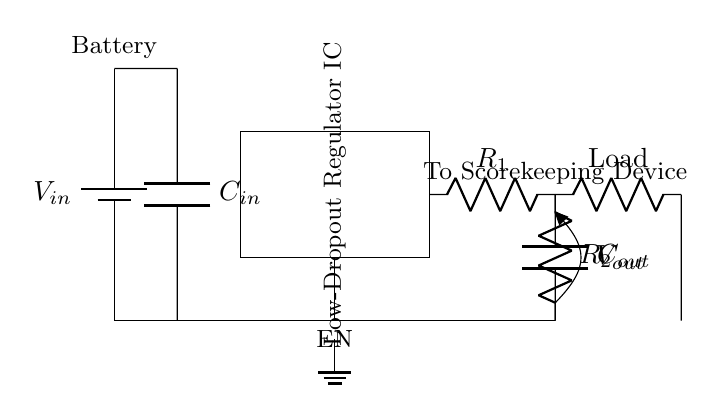What is the type of voltage source used in this circuit? The circuit includes a battery, which is indicated with the label "Battery" at the top left corner. A battery is a type of voltage source.
Answer: Battery What is the role of capacitor C_in? Capacitor C_in is placed at the input side of the LDO regulator, helping to stabilize the input voltage by filtering out noise and providing charge during sudden load changes.
Answer: Stabilization What is the output voltage of the circuit? The output voltage is represented by "V_out", which is connected to the load and is the voltage supplied to the scorekeeping device.
Answer: V_out How many feedback resistors are present in the circuit? There are two feedback resistors, labeled R_1 and R_2, connected to the output of the LDO regulator in a voltage divider configuration.
Answer: Two What is the purpose of the enable pin in this circuit? The enable pin (EN) controls the operation of the LDO regulator, allowing it to turn on or off based on the control signal it receives.
Answer: Control Why is a Low-Dropout regulator used here? A Low-Dropout regulator is designed to operate with a small voltage difference between input and output, making it suitable for battery-powered devices where efficient voltage regulation is critical.
Answer: Efficiency What is connected to the output of this LDO regulator? The output is connected to a load, which represents the scorekeeping device that requires a steady voltage for operation.
Answer: Load 